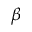<formula> <loc_0><loc_0><loc_500><loc_500>\beta</formula> 